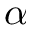<formula> <loc_0><loc_0><loc_500><loc_500>\alpha</formula> 